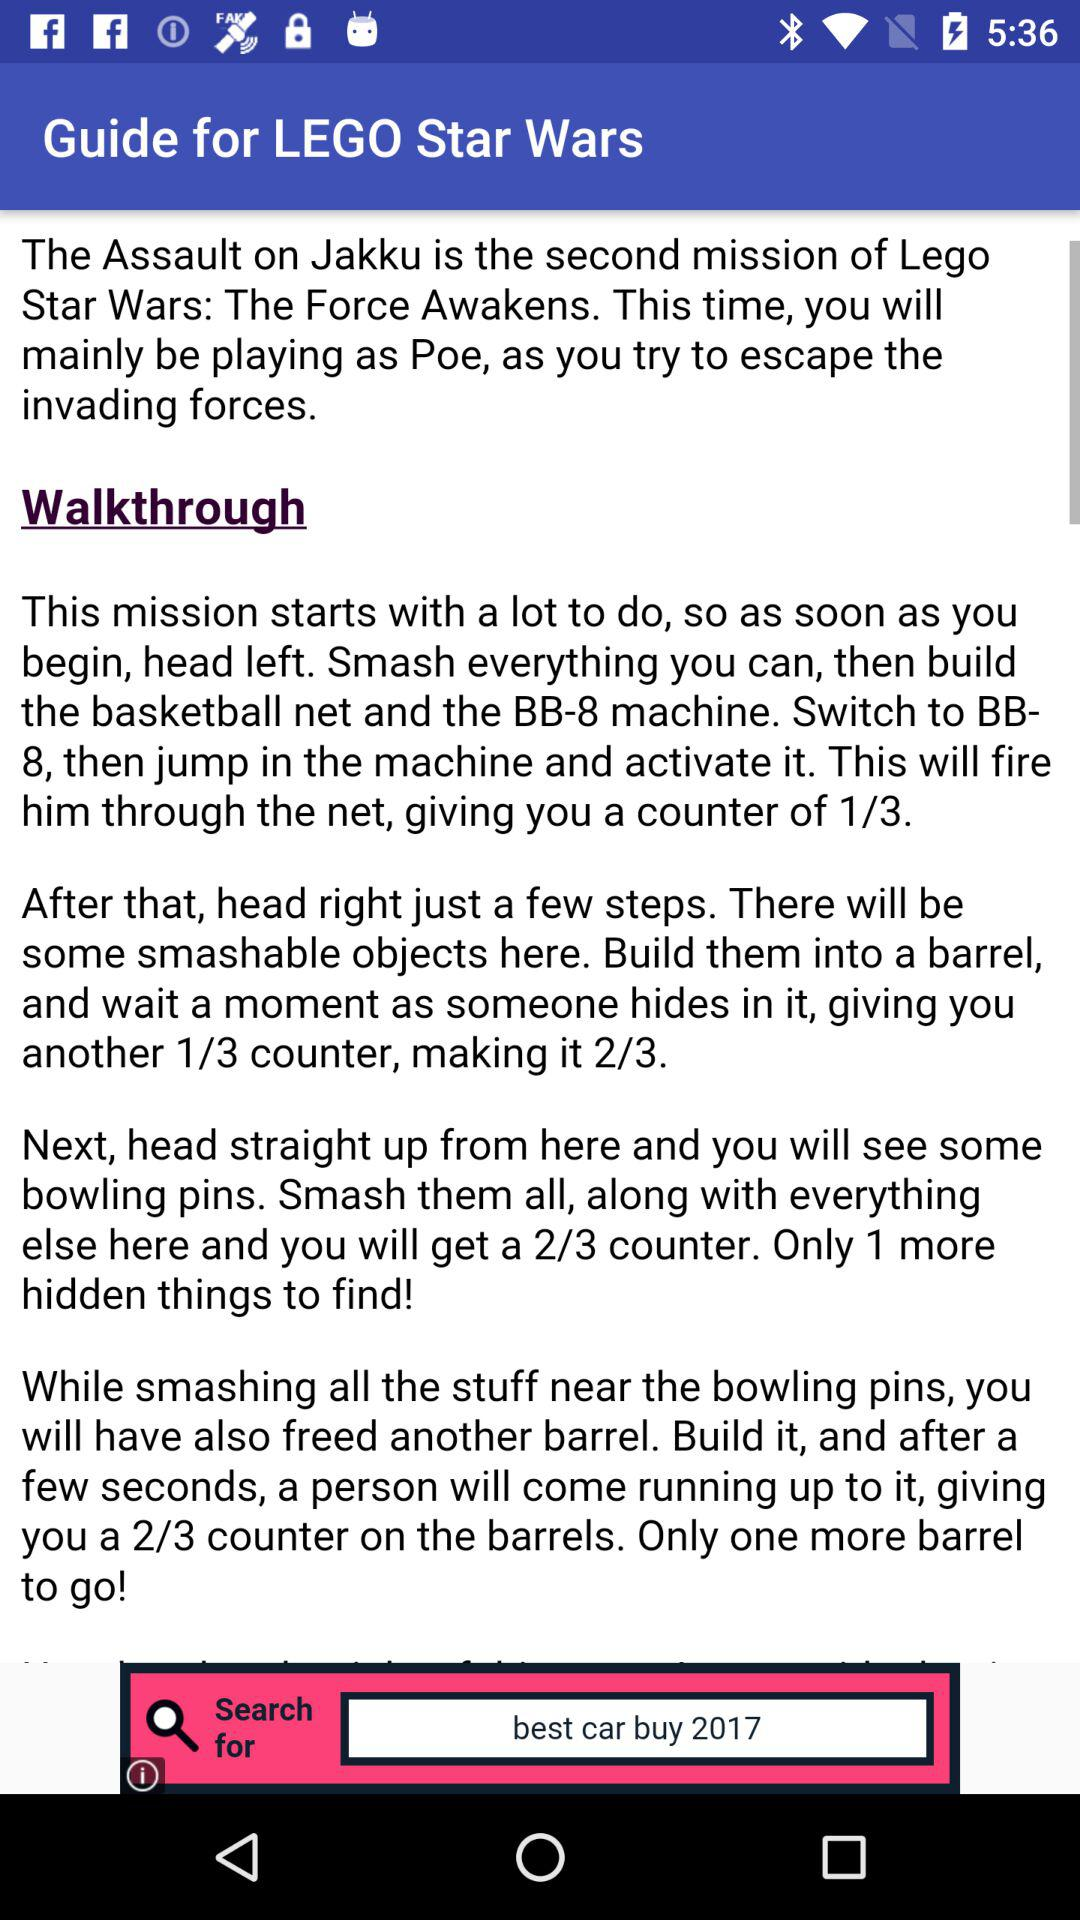How many more barrels do you need to find?
Answer the question using a single word or phrase. 1 